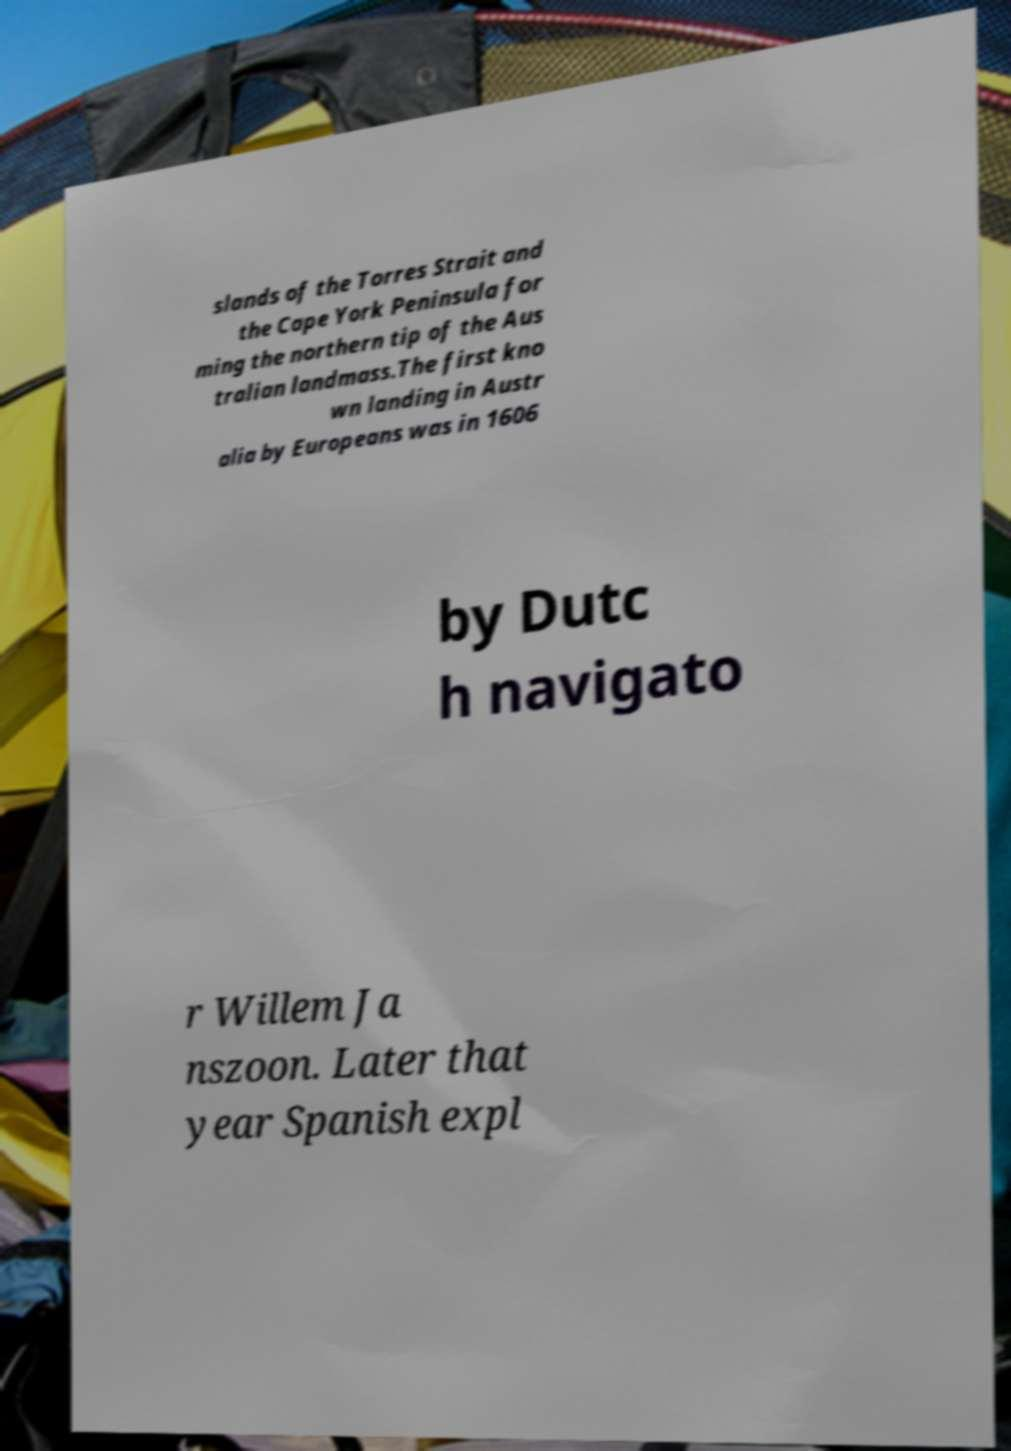Please identify and transcribe the text found in this image. slands of the Torres Strait and the Cape York Peninsula for ming the northern tip of the Aus tralian landmass.The first kno wn landing in Austr alia by Europeans was in 1606 by Dutc h navigato r Willem Ja nszoon. Later that year Spanish expl 